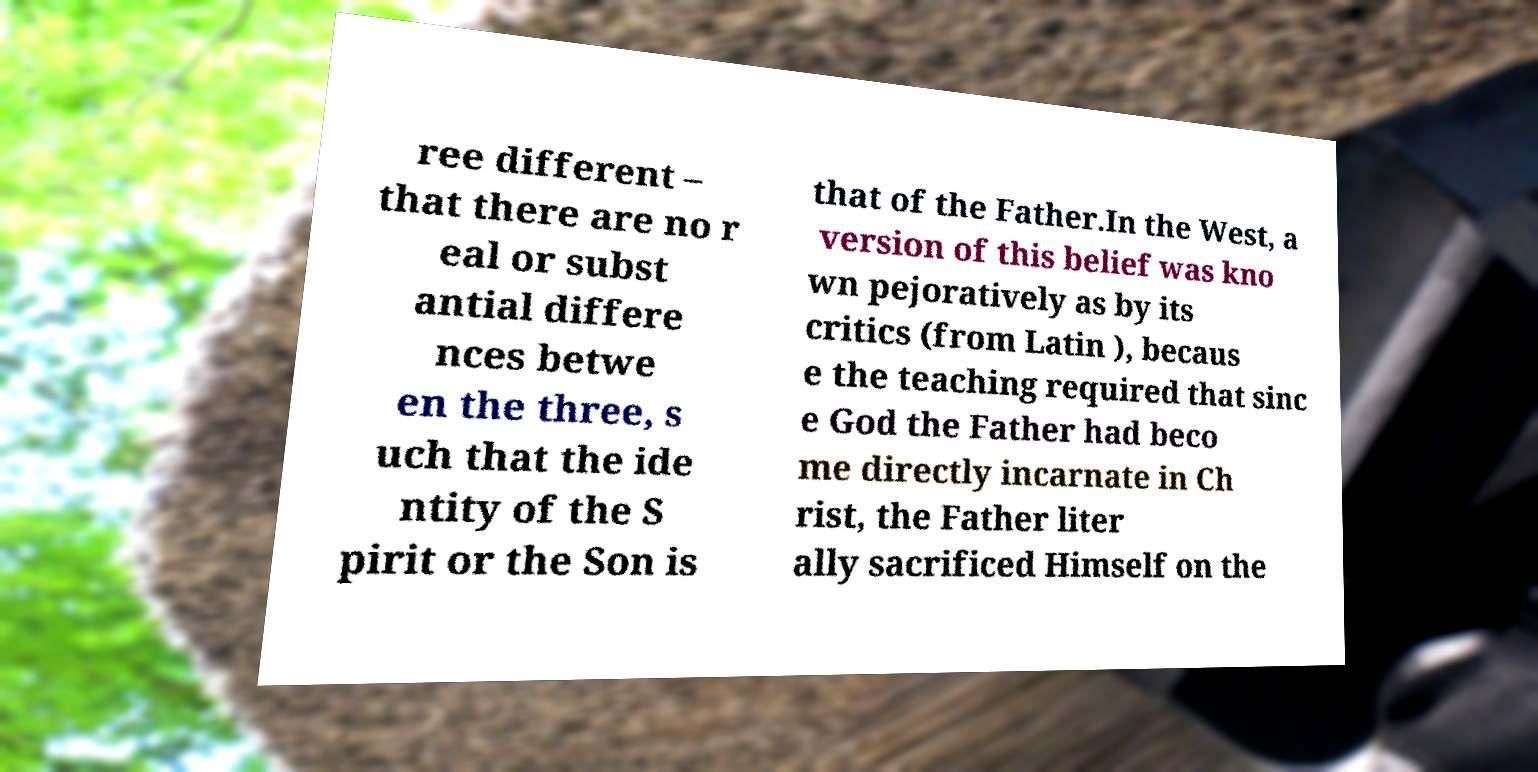Could you extract and type out the text from this image? ree different – that there are no r eal or subst antial differe nces betwe en the three, s uch that the ide ntity of the S pirit or the Son is that of the Father.In the West, a version of this belief was kno wn pejoratively as by its critics (from Latin ), becaus e the teaching required that sinc e God the Father had beco me directly incarnate in Ch rist, the Father liter ally sacrificed Himself on the 